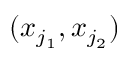Convert formula to latex. <formula><loc_0><loc_0><loc_500><loc_500>( x _ { j _ { 1 } } , x _ { j _ { 2 } } )</formula> 